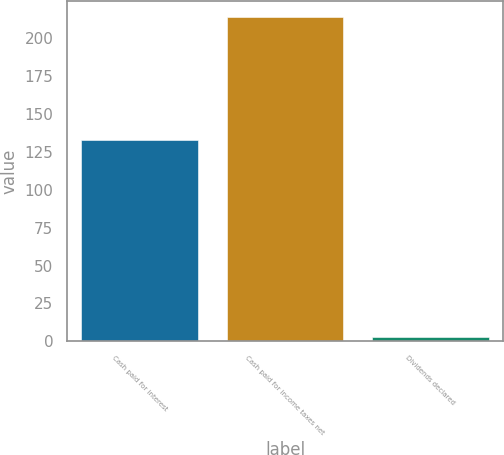Convert chart to OTSL. <chart><loc_0><loc_0><loc_500><loc_500><bar_chart><fcel>Cash paid for interest<fcel>Cash paid for income taxes net<fcel>Dividends declared<nl><fcel>133<fcel>214<fcel>3<nl></chart> 